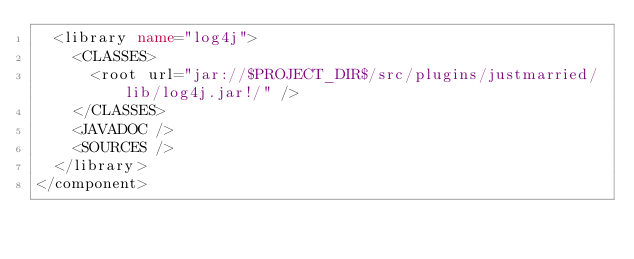Convert code to text. <code><loc_0><loc_0><loc_500><loc_500><_XML_>  <library name="log4j">
    <CLASSES>
      <root url="jar://$PROJECT_DIR$/src/plugins/justmarried/lib/log4j.jar!/" />
    </CLASSES>
    <JAVADOC />
    <SOURCES />
  </library>
</component></code> 